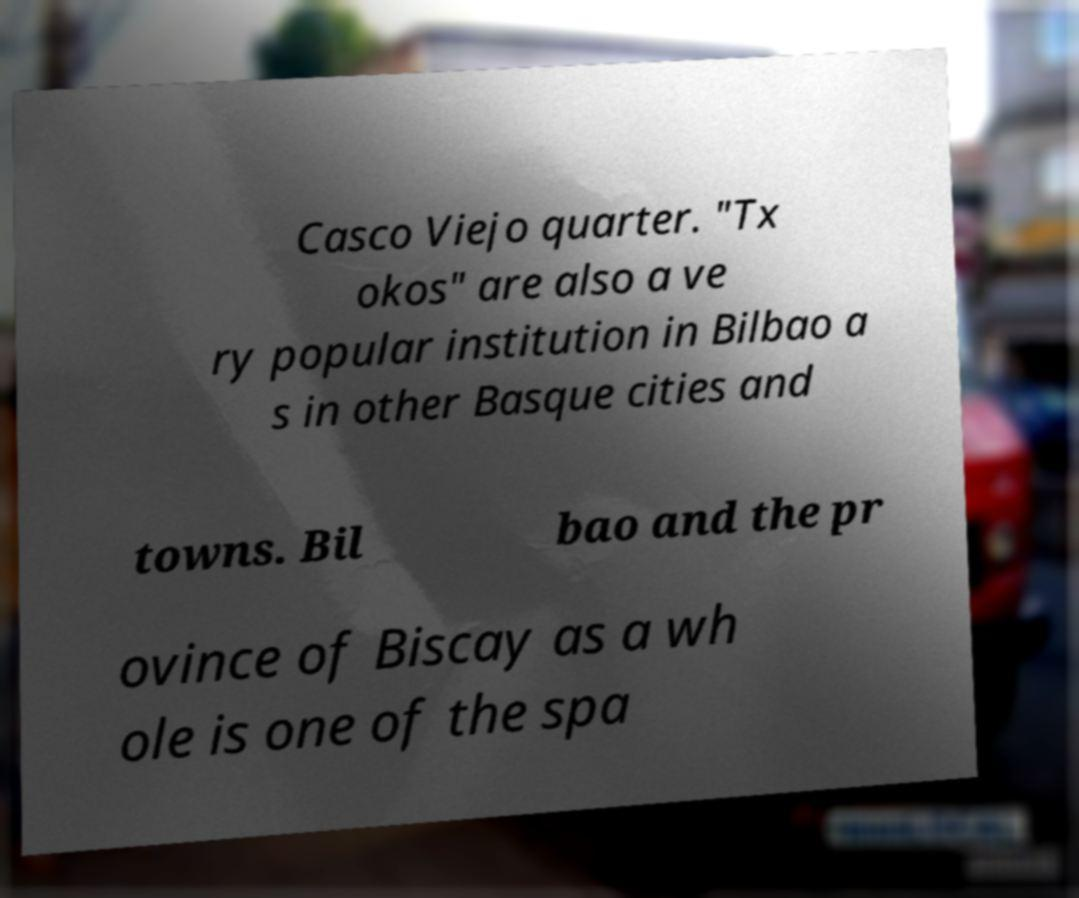For documentation purposes, I need the text within this image transcribed. Could you provide that? Casco Viejo quarter. "Tx okos" are also a ve ry popular institution in Bilbao a s in other Basque cities and towns. Bil bao and the pr ovince of Biscay as a wh ole is one of the spa 